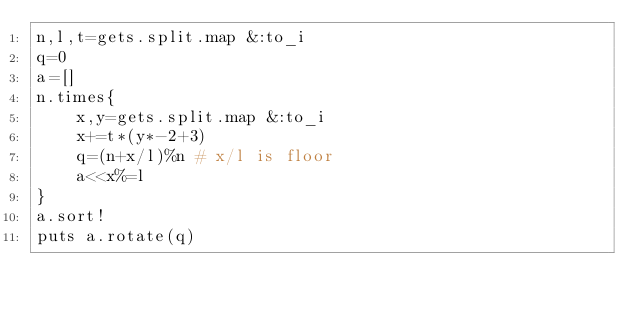Convert code to text. <code><loc_0><loc_0><loc_500><loc_500><_Ruby_>n,l,t=gets.split.map &:to_i
q=0
a=[]
n.times{
	x,y=gets.split.map &:to_i
	x+=t*(y*-2+3)
	q=(n+x/l)%n # x/l is floor
	a<<x%=l
}
a.sort!
puts a.rotate(q)</code> 